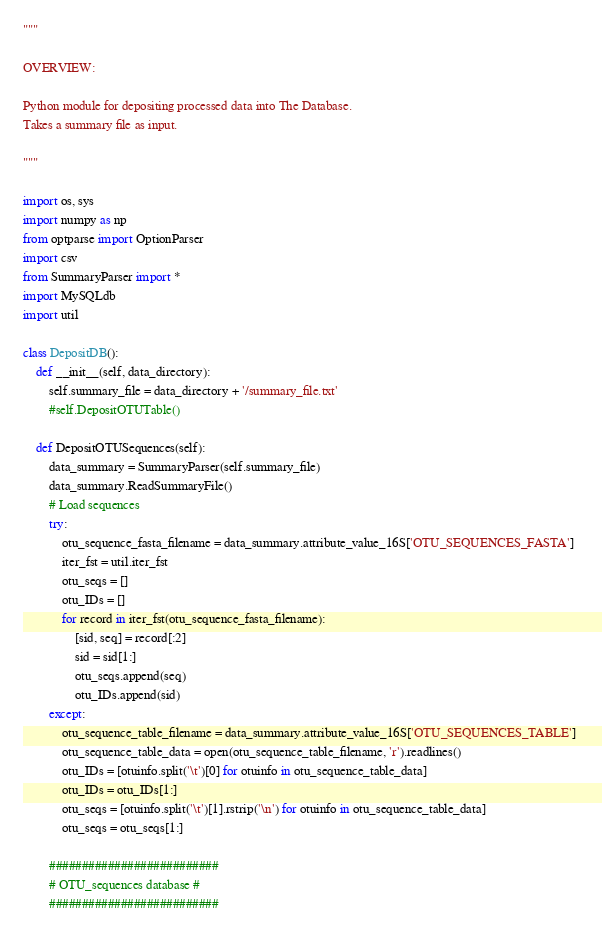Convert code to text. <code><loc_0><loc_0><loc_500><loc_500><_Python_>"""

OVERVIEW: 

Python module for depositing processed data into The Database.
Takes a summary file as input.

"""

import os, sys
import numpy as np
from optparse import OptionParser
import csv
from SummaryParser import *
import MySQLdb
import util

class DepositDB():
    def __init__(self, data_directory):
        self.summary_file = data_directory + '/summary_file.txt'
        #self.DepositOTUTable()

    def DepositOTUSequences(self):
        data_summary = SummaryParser(self.summary_file)
        data_summary.ReadSummaryFile()        
        # Load sequences
        try:
            otu_sequence_fasta_filename = data_summary.attribute_value_16S['OTU_SEQUENCES_FASTA']
            iter_fst = util.iter_fst
            otu_seqs = []
            otu_IDs = []
            for record in iter_fst(otu_sequence_fasta_filename):
                [sid, seq] = record[:2]
                sid = sid[1:]
                otu_seqs.append(seq)
                otu_IDs.append(sid)        
        except:
            otu_sequence_table_filename = data_summary.attribute_value_16S['OTU_SEQUENCES_TABLE'] 
            otu_sequence_table_data = open(otu_sequence_table_filename, 'r').readlines()
            otu_IDs = [otuinfo.split('\t')[0] for otuinfo in otu_sequence_table_data]
            otu_IDs = otu_IDs[1:]
            otu_seqs = [otuinfo.split('\t')[1].rstrip('\n') for otuinfo in otu_sequence_table_data]
            otu_seqs = otu_seqs[1:]

        ##########################
        # OTU_sequences database #
        ##########################</code> 